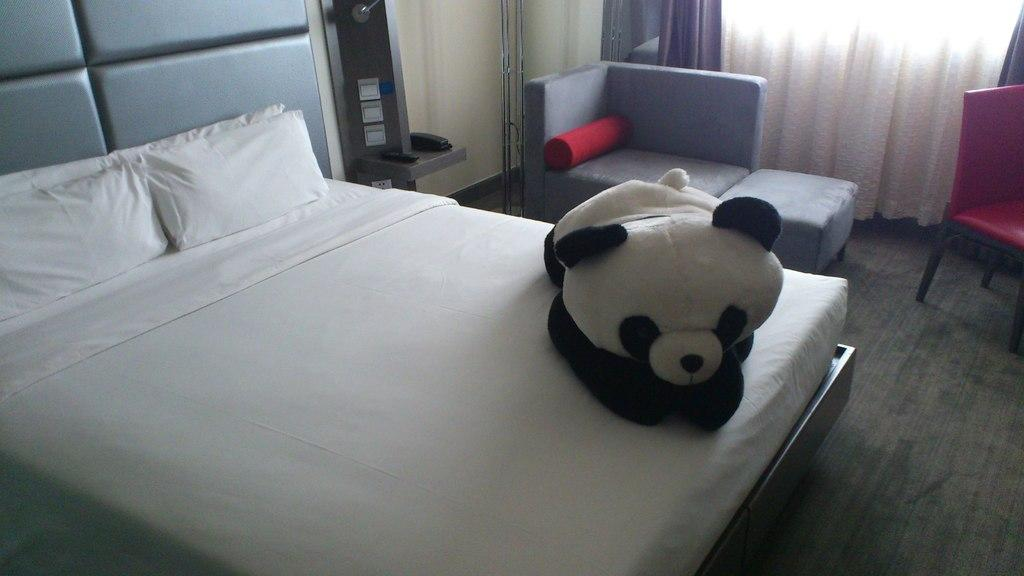What is the main object in the center of the image? There is a bed in the center of the image. What type of toy is on the bed? There is a toy panda on the bed. What are the pillows used for on the bed? The pillows are used for comfort and support while sleeping or resting on the bed. What can be seen in the background of the image? There are chairs and a curtain in the background of the image. What nation is rewarded for their property in the image? There is no reference to a nation, reward, or property in the image. 